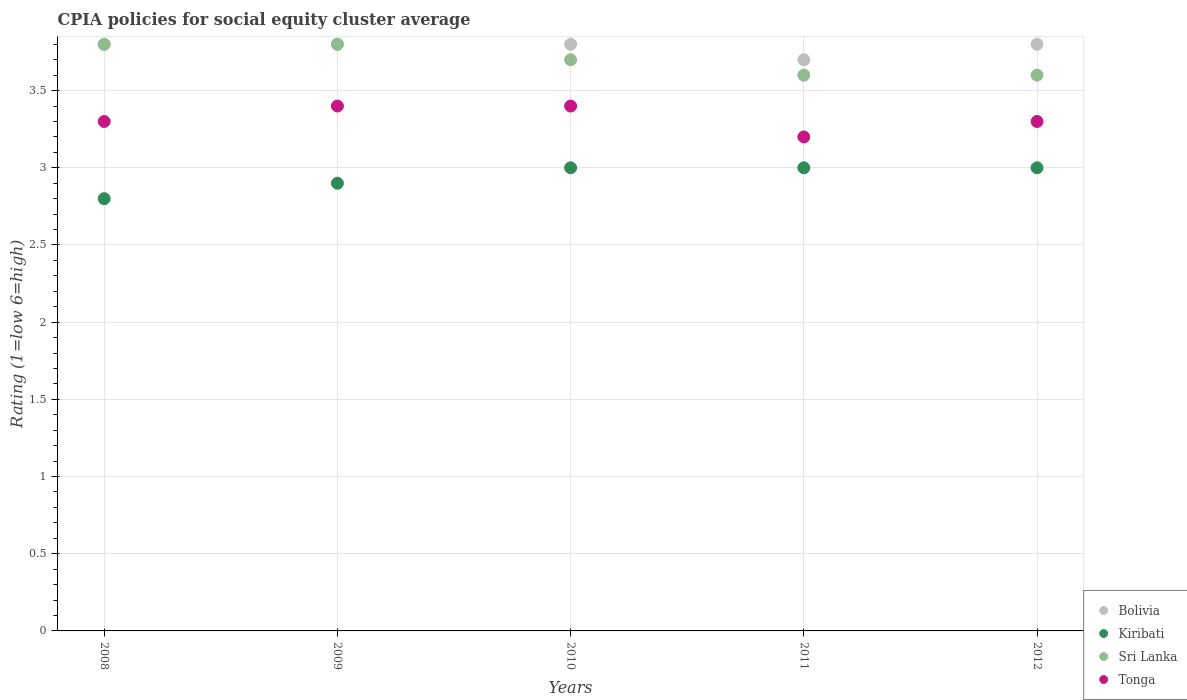What is the CPIA rating in Bolivia in 2011?
Give a very brief answer. 3.7. In which year was the CPIA rating in Tonga maximum?
Provide a succinct answer. 2009. In which year was the CPIA rating in Bolivia minimum?
Keep it short and to the point. 2011. What is the difference between the CPIA rating in Kiribati in 2008 and that in 2011?
Ensure brevity in your answer.  -0.2. What is the difference between the CPIA rating in Kiribati in 2012 and the CPIA rating in Sri Lanka in 2009?
Ensure brevity in your answer.  -0.8. What is the average CPIA rating in Sri Lanka per year?
Give a very brief answer. 3.7. In the year 2012, what is the difference between the CPIA rating in Bolivia and CPIA rating in Sri Lanka?
Provide a short and direct response. 0.2. In how many years, is the CPIA rating in Kiribati greater than 2.1?
Make the answer very short. 5. What is the ratio of the CPIA rating in Tonga in 2008 to that in 2009?
Your response must be concise. 0.97. What is the difference between the highest and the lowest CPIA rating in Sri Lanka?
Make the answer very short. 0.2. Is the sum of the CPIA rating in Tonga in 2009 and 2010 greater than the maximum CPIA rating in Kiribati across all years?
Ensure brevity in your answer.  Yes. Is it the case that in every year, the sum of the CPIA rating in Sri Lanka and CPIA rating in Tonga  is greater than the CPIA rating in Bolivia?
Provide a short and direct response. Yes. Does the CPIA rating in Tonga monotonically increase over the years?
Provide a succinct answer. No. Is the CPIA rating in Kiribati strictly greater than the CPIA rating in Tonga over the years?
Give a very brief answer. No. How many dotlines are there?
Your answer should be very brief. 4. Does the graph contain any zero values?
Your answer should be very brief. No. Does the graph contain grids?
Make the answer very short. Yes. How are the legend labels stacked?
Provide a short and direct response. Vertical. What is the title of the graph?
Provide a succinct answer. CPIA policies for social equity cluster average. What is the label or title of the X-axis?
Make the answer very short. Years. What is the label or title of the Y-axis?
Your answer should be very brief. Rating (1=low 6=high). What is the Rating (1=low 6=high) of Bolivia in 2008?
Provide a short and direct response. 3.8. What is the Rating (1=low 6=high) of Sri Lanka in 2008?
Your answer should be very brief. 3.8. What is the Rating (1=low 6=high) in Tonga in 2008?
Make the answer very short. 3.3. What is the Rating (1=low 6=high) of Kiribati in 2009?
Your response must be concise. 2.9. What is the Rating (1=low 6=high) of Sri Lanka in 2009?
Your answer should be very brief. 3.8. What is the Rating (1=low 6=high) in Bolivia in 2010?
Provide a short and direct response. 3.8. What is the Rating (1=low 6=high) in Kiribati in 2010?
Your answer should be compact. 3. What is the Rating (1=low 6=high) in Sri Lanka in 2010?
Your answer should be compact. 3.7. What is the Rating (1=low 6=high) in Bolivia in 2011?
Provide a succinct answer. 3.7. What is the Rating (1=low 6=high) of Kiribati in 2011?
Keep it short and to the point. 3. What is the Rating (1=low 6=high) of Tonga in 2011?
Ensure brevity in your answer.  3.2. Across all years, what is the maximum Rating (1=low 6=high) of Bolivia?
Offer a very short reply. 3.8. Across all years, what is the maximum Rating (1=low 6=high) in Tonga?
Your response must be concise. 3.4. Across all years, what is the minimum Rating (1=low 6=high) in Sri Lanka?
Keep it short and to the point. 3.6. What is the total Rating (1=low 6=high) of Kiribati in the graph?
Keep it short and to the point. 14.7. What is the total Rating (1=low 6=high) in Sri Lanka in the graph?
Your response must be concise. 18.5. What is the difference between the Rating (1=low 6=high) in Kiribati in 2008 and that in 2009?
Your answer should be compact. -0.1. What is the difference between the Rating (1=low 6=high) of Sri Lanka in 2008 and that in 2009?
Your answer should be compact. 0. What is the difference between the Rating (1=low 6=high) in Bolivia in 2008 and that in 2010?
Keep it short and to the point. 0. What is the difference between the Rating (1=low 6=high) in Tonga in 2008 and that in 2010?
Offer a very short reply. -0.1. What is the difference between the Rating (1=low 6=high) in Bolivia in 2008 and that in 2011?
Make the answer very short. 0.1. What is the difference between the Rating (1=low 6=high) of Sri Lanka in 2008 and that in 2011?
Your response must be concise. 0.2. What is the difference between the Rating (1=low 6=high) of Bolivia in 2008 and that in 2012?
Ensure brevity in your answer.  0. What is the difference between the Rating (1=low 6=high) in Kiribati in 2008 and that in 2012?
Your response must be concise. -0.2. What is the difference between the Rating (1=low 6=high) in Tonga in 2008 and that in 2012?
Give a very brief answer. 0. What is the difference between the Rating (1=low 6=high) of Kiribati in 2009 and that in 2010?
Provide a short and direct response. -0.1. What is the difference between the Rating (1=low 6=high) in Bolivia in 2009 and that in 2011?
Your response must be concise. 0.1. What is the difference between the Rating (1=low 6=high) in Kiribati in 2009 and that in 2011?
Your response must be concise. -0.1. What is the difference between the Rating (1=low 6=high) of Kiribati in 2009 and that in 2012?
Offer a terse response. -0.1. What is the difference between the Rating (1=low 6=high) in Sri Lanka in 2009 and that in 2012?
Your answer should be very brief. 0.2. What is the difference between the Rating (1=low 6=high) in Tonga in 2009 and that in 2012?
Give a very brief answer. 0.1. What is the difference between the Rating (1=low 6=high) in Bolivia in 2010 and that in 2011?
Provide a succinct answer. 0.1. What is the difference between the Rating (1=low 6=high) in Kiribati in 2010 and that in 2011?
Ensure brevity in your answer.  0. What is the difference between the Rating (1=low 6=high) of Sri Lanka in 2010 and that in 2011?
Your answer should be very brief. 0.1. What is the difference between the Rating (1=low 6=high) of Tonga in 2010 and that in 2011?
Your answer should be very brief. 0.2. What is the difference between the Rating (1=low 6=high) in Bolivia in 2010 and that in 2012?
Provide a succinct answer. 0. What is the difference between the Rating (1=low 6=high) of Kiribati in 2010 and that in 2012?
Give a very brief answer. 0. What is the difference between the Rating (1=low 6=high) in Sri Lanka in 2010 and that in 2012?
Offer a terse response. 0.1. What is the difference between the Rating (1=low 6=high) of Tonga in 2010 and that in 2012?
Provide a short and direct response. 0.1. What is the difference between the Rating (1=low 6=high) of Bolivia in 2011 and that in 2012?
Your answer should be compact. -0.1. What is the difference between the Rating (1=low 6=high) of Sri Lanka in 2011 and that in 2012?
Keep it short and to the point. 0. What is the difference between the Rating (1=low 6=high) of Bolivia in 2008 and the Rating (1=low 6=high) of Kiribati in 2009?
Provide a short and direct response. 0.9. What is the difference between the Rating (1=low 6=high) in Bolivia in 2008 and the Rating (1=low 6=high) in Tonga in 2009?
Keep it short and to the point. 0.4. What is the difference between the Rating (1=low 6=high) of Kiribati in 2008 and the Rating (1=low 6=high) of Tonga in 2009?
Keep it short and to the point. -0.6. What is the difference between the Rating (1=low 6=high) of Bolivia in 2008 and the Rating (1=low 6=high) of Kiribati in 2010?
Offer a very short reply. 0.8. What is the difference between the Rating (1=low 6=high) in Bolivia in 2008 and the Rating (1=low 6=high) in Sri Lanka in 2010?
Ensure brevity in your answer.  0.1. What is the difference between the Rating (1=low 6=high) of Kiribati in 2008 and the Rating (1=low 6=high) of Sri Lanka in 2010?
Offer a terse response. -0.9. What is the difference between the Rating (1=low 6=high) in Sri Lanka in 2008 and the Rating (1=low 6=high) in Tonga in 2010?
Offer a terse response. 0.4. What is the difference between the Rating (1=low 6=high) of Bolivia in 2008 and the Rating (1=low 6=high) of Kiribati in 2011?
Offer a very short reply. 0.8. What is the difference between the Rating (1=low 6=high) in Bolivia in 2008 and the Rating (1=low 6=high) in Sri Lanka in 2011?
Your answer should be very brief. 0.2. What is the difference between the Rating (1=low 6=high) in Sri Lanka in 2008 and the Rating (1=low 6=high) in Tonga in 2011?
Offer a terse response. 0.6. What is the difference between the Rating (1=low 6=high) of Bolivia in 2008 and the Rating (1=low 6=high) of Kiribati in 2012?
Offer a terse response. 0.8. What is the difference between the Rating (1=low 6=high) in Bolivia in 2008 and the Rating (1=low 6=high) in Tonga in 2012?
Ensure brevity in your answer.  0.5. What is the difference between the Rating (1=low 6=high) in Bolivia in 2009 and the Rating (1=low 6=high) in Kiribati in 2010?
Provide a short and direct response. 0.8. What is the difference between the Rating (1=low 6=high) in Bolivia in 2009 and the Rating (1=low 6=high) in Sri Lanka in 2010?
Give a very brief answer. 0.1. What is the difference between the Rating (1=low 6=high) of Bolivia in 2009 and the Rating (1=low 6=high) of Tonga in 2010?
Your answer should be compact. 0.4. What is the difference between the Rating (1=low 6=high) of Kiribati in 2009 and the Rating (1=low 6=high) of Sri Lanka in 2010?
Keep it short and to the point. -0.8. What is the difference between the Rating (1=low 6=high) in Bolivia in 2009 and the Rating (1=low 6=high) in Kiribati in 2011?
Your response must be concise. 0.8. What is the difference between the Rating (1=low 6=high) in Bolivia in 2009 and the Rating (1=low 6=high) in Sri Lanka in 2011?
Provide a succinct answer. 0.2. What is the difference between the Rating (1=low 6=high) in Bolivia in 2009 and the Rating (1=low 6=high) in Tonga in 2011?
Keep it short and to the point. 0.6. What is the difference between the Rating (1=low 6=high) in Kiribati in 2009 and the Rating (1=low 6=high) in Sri Lanka in 2011?
Your answer should be very brief. -0.7. What is the difference between the Rating (1=low 6=high) in Bolivia in 2009 and the Rating (1=low 6=high) in Sri Lanka in 2012?
Ensure brevity in your answer.  0.2. What is the difference between the Rating (1=low 6=high) of Bolivia in 2010 and the Rating (1=low 6=high) of Kiribati in 2011?
Offer a very short reply. 0.8. What is the difference between the Rating (1=low 6=high) in Bolivia in 2010 and the Rating (1=low 6=high) in Sri Lanka in 2011?
Your answer should be compact. 0.2. What is the difference between the Rating (1=low 6=high) of Bolivia in 2010 and the Rating (1=low 6=high) of Tonga in 2011?
Your answer should be compact. 0.6. What is the difference between the Rating (1=low 6=high) of Kiribati in 2010 and the Rating (1=low 6=high) of Tonga in 2011?
Provide a short and direct response. -0.2. What is the difference between the Rating (1=low 6=high) of Sri Lanka in 2010 and the Rating (1=low 6=high) of Tonga in 2011?
Your answer should be compact. 0.5. What is the difference between the Rating (1=low 6=high) of Bolivia in 2010 and the Rating (1=low 6=high) of Kiribati in 2012?
Keep it short and to the point. 0.8. What is the difference between the Rating (1=low 6=high) of Bolivia in 2010 and the Rating (1=low 6=high) of Tonga in 2012?
Make the answer very short. 0.5. What is the difference between the Rating (1=low 6=high) in Kiribati in 2010 and the Rating (1=low 6=high) in Tonga in 2012?
Give a very brief answer. -0.3. What is the difference between the Rating (1=low 6=high) of Sri Lanka in 2010 and the Rating (1=low 6=high) of Tonga in 2012?
Provide a short and direct response. 0.4. What is the difference between the Rating (1=low 6=high) in Bolivia in 2011 and the Rating (1=low 6=high) in Kiribati in 2012?
Ensure brevity in your answer.  0.7. What is the difference between the Rating (1=low 6=high) in Bolivia in 2011 and the Rating (1=low 6=high) in Tonga in 2012?
Give a very brief answer. 0.4. What is the difference between the Rating (1=low 6=high) of Kiribati in 2011 and the Rating (1=low 6=high) of Sri Lanka in 2012?
Offer a very short reply. -0.6. What is the average Rating (1=low 6=high) in Bolivia per year?
Make the answer very short. 3.78. What is the average Rating (1=low 6=high) in Kiribati per year?
Provide a short and direct response. 2.94. What is the average Rating (1=low 6=high) of Sri Lanka per year?
Ensure brevity in your answer.  3.7. What is the average Rating (1=low 6=high) in Tonga per year?
Keep it short and to the point. 3.32. In the year 2008, what is the difference between the Rating (1=low 6=high) in Bolivia and Rating (1=low 6=high) in Kiribati?
Provide a short and direct response. 1. In the year 2008, what is the difference between the Rating (1=low 6=high) in Kiribati and Rating (1=low 6=high) in Sri Lanka?
Offer a terse response. -1. In the year 2009, what is the difference between the Rating (1=low 6=high) in Bolivia and Rating (1=low 6=high) in Kiribati?
Offer a terse response. 0.9. In the year 2009, what is the difference between the Rating (1=low 6=high) in Bolivia and Rating (1=low 6=high) in Sri Lanka?
Your answer should be very brief. 0. In the year 2009, what is the difference between the Rating (1=low 6=high) in Bolivia and Rating (1=low 6=high) in Tonga?
Provide a short and direct response. 0.4. In the year 2009, what is the difference between the Rating (1=low 6=high) of Kiribati and Rating (1=low 6=high) of Tonga?
Make the answer very short. -0.5. In the year 2009, what is the difference between the Rating (1=low 6=high) in Sri Lanka and Rating (1=low 6=high) in Tonga?
Ensure brevity in your answer.  0.4. In the year 2010, what is the difference between the Rating (1=low 6=high) of Bolivia and Rating (1=low 6=high) of Tonga?
Give a very brief answer. 0.4. In the year 2010, what is the difference between the Rating (1=low 6=high) of Sri Lanka and Rating (1=low 6=high) of Tonga?
Offer a very short reply. 0.3. In the year 2012, what is the difference between the Rating (1=low 6=high) of Bolivia and Rating (1=low 6=high) of Sri Lanka?
Your answer should be very brief. 0.2. In the year 2012, what is the difference between the Rating (1=low 6=high) of Bolivia and Rating (1=low 6=high) of Tonga?
Provide a succinct answer. 0.5. What is the ratio of the Rating (1=low 6=high) of Bolivia in 2008 to that in 2009?
Ensure brevity in your answer.  1. What is the ratio of the Rating (1=low 6=high) in Kiribati in 2008 to that in 2009?
Offer a very short reply. 0.97. What is the ratio of the Rating (1=low 6=high) in Tonga in 2008 to that in 2009?
Provide a short and direct response. 0.97. What is the ratio of the Rating (1=low 6=high) of Bolivia in 2008 to that in 2010?
Ensure brevity in your answer.  1. What is the ratio of the Rating (1=low 6=high) in Kiribati in 2008 to that in 2010?
Keep it short and to the point. 0.93. What is the ratio of the Rating (1=low 6=high) of Sri Lanka in 2008 to that in 2010?
Give a very brief answer. 1.03. What is the ratio of the Rating (1=low 6=high) of Tonga in 2008 to that in 2010?
Make the answer very short. 0.97. What is the ratio of the Rating (1=low 6=high) of Bolivia in 2008 to that in 2011?
Provide a short and direct response. 1.03. What is the ratio of the Rating (1=low 6=high) in Kiribati in 2008 to that in 2011?
Offer a very short reply. 0.93. What is the ratio of the Rating (1=low 6=high) in Sri Lanka in 2008 to that in 2011?
Your answer should be very brief. 1.06. What is the ratio of the Rating (1=low 6=high) of Tonga in 2008 to that in 2011?
Provide a succinct answer. 1.03. What is the ratio of the Rating (1=low 6=high) of Bolivia in 2008 to that in 2012?
Offer a very short reply. 1. What is the ratio of the Rating (1=low 6=high) of Sri Lanka in 2008 to that in 2012?
Your response must be concise. 1.06. What is the ratio of the Rating (1=low 6=high) in Tonga in 2008 to that in 2012?
Ensure brevity in your answer.  1. What is the ratio of the Rating (1=low 6=high) of Kiribati in 2009 to that in 2010?
Your answer should be compact. 0.97. What is the ratio of the Rating (1=low 6=high) in Sri Lanka in 2009 to that in 2010?
Provide a short and direct response. 1.03. What is the ratio of the Rating (1=low 6=high) in Bolivia in 2009 to that in 2011?
Your answer should be very brief. 1.03. What is the ratio of the Rating (1=low 6=high) in Kiribati in 2009 to that in 2011?
Make the answer very short. 0.97. What is the ratio of the Rating (1=low 6=high) of Sri Lanka in 2009 to that in 2011?
Make the answer very short. 1.06. What is the ratio of the Rating (1=low 6=high) in Kiribati in 2009 to that in 2012?
Ensure brevity in your answer.  0.97. What is the ratio of the Rating (1=low 6=high) of Sri Lanka in 2009 to that in 2012?
Your answer should be very brief. 1.06. What is the ratio of the Rating (1=low 6=high) in Tonga in 2009 to that in 2012?
Ensure brevity in your answer.  1.03. What is the ratio of the Rating (1=low 6=high) in Kiribati in 2010 to that in 2011?
Offer a terse response. 1. What is the ratio of the Rating (1=low 6=high) in Sri Lanka in 2010 to that in 2011?
Your response must be concise. 1.03. What is the ratio of the Rating (1=low 6=high) of Bolivia in 2010 to that in 2012?
Your answer should be compact. 1. What is the ratio of the Rating (1=low 6=high) in Sri Lanka in 2010 to that in 2012?
Your answer should be very brief. 1.03. What is the ratio of the Rating (1=low 6=high) of Tonga in 2010 to that in 2012?
Give a very brief answer. 1.03. What is the ratio of the Rating (1=low 6=high) of Bolivia in 2011 to that in 2012?
Keep it short and to the point. 0.97. What is the ratio of the Rating (1=low 6=high) in Sri Lanka in 2011 to that in 2012?
Your response must be concise. 1. What is the ratio of the Rating (1=low 6=high) in Tonga in 2011 to that in 2012?
Ensure brevity in your answer.  0.97. What is the difference between the highest and the second highest Rating (1=low 6=high) of Kiribati?
Your answer should be very brief. 0. What is the difference between the highest and the second highest Rating (1=low 6=high) of Sri Lanka?
Give a very brief answer. 0. What is the difference between the highest and the lowest Rating (1=low 6=high) in Kiribati?
Your answer should be very brief. 0.2. 